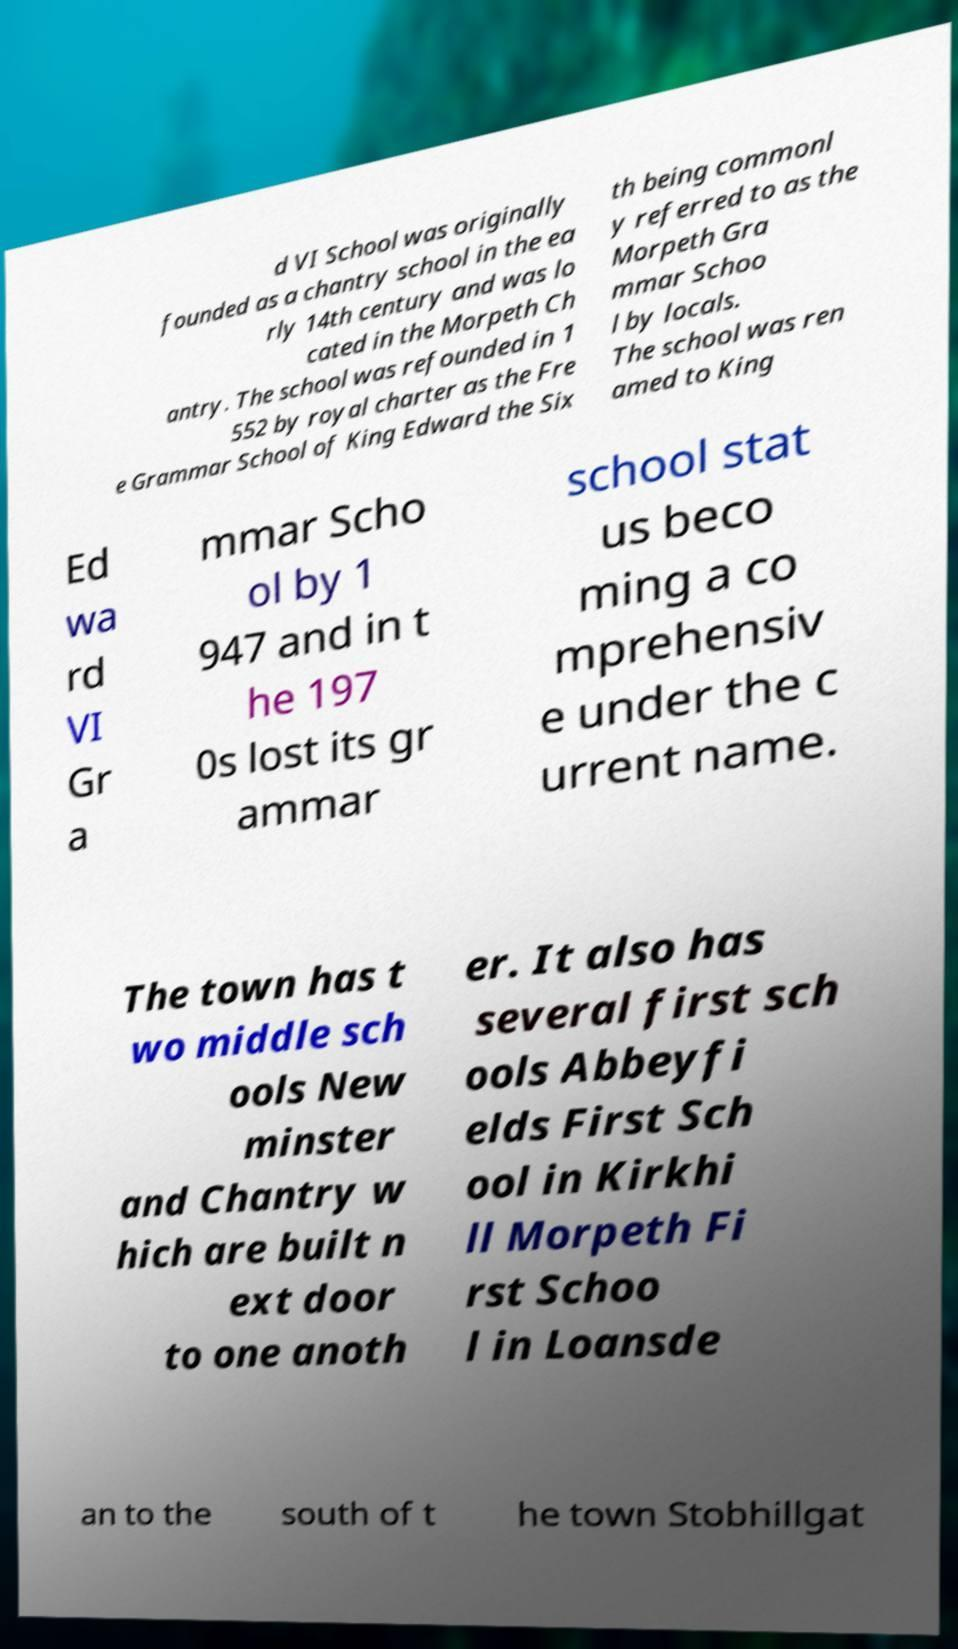Please read and relay the text visible in this image. What does it say? d VI School was originally founded as a chantry school in the ea rly 14th century and was lo cated in the Morpeth Ch antry. The school was refounded in 1 552 by royal charter as the Fre e Grammar School of King Edward the Six th being commonl y referred to as the Morpeth Gra mmar Schoo l by locals. The school was ren amed to King Ed wa rd VI Gr a mmar Scho ol by 1 947 and in t he 197 0s lost its gr ammar school stat us beco ming a co mprehensiv e under the c urrent name. The town has t wo middle sch ools New minster and Chantry w hich are built n ext door to one anoth er. It also has several first sch ools Abbeyfi elds First Sch ool in Kirkhi ll Morpeth Fi rst Schoo l in Loansde an to the south of t he town Stobhillgat 